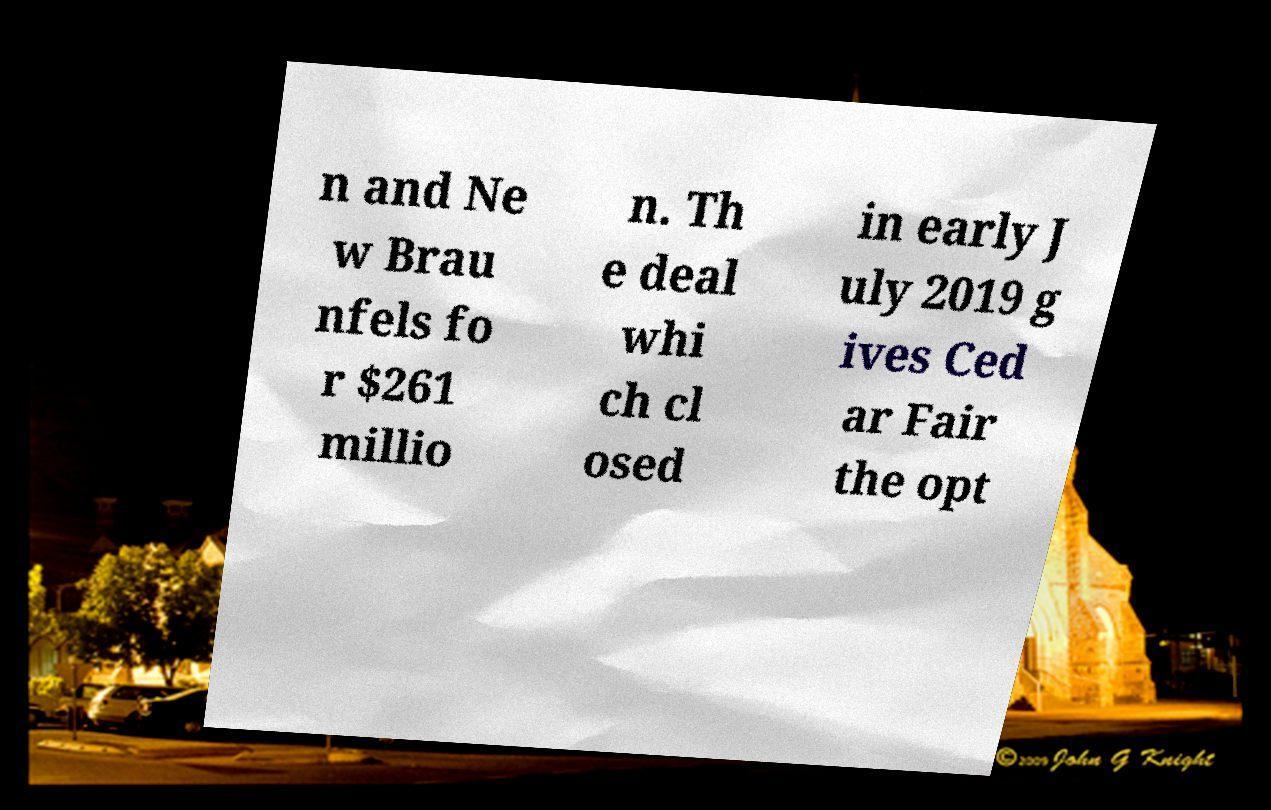Could you extract and type out the text from this image? n and Ne w Brau nfels fo r $261 millio n. Th e deal whi ch cl osed in early J uly 2019 g ives Ced ar Fair the opt 